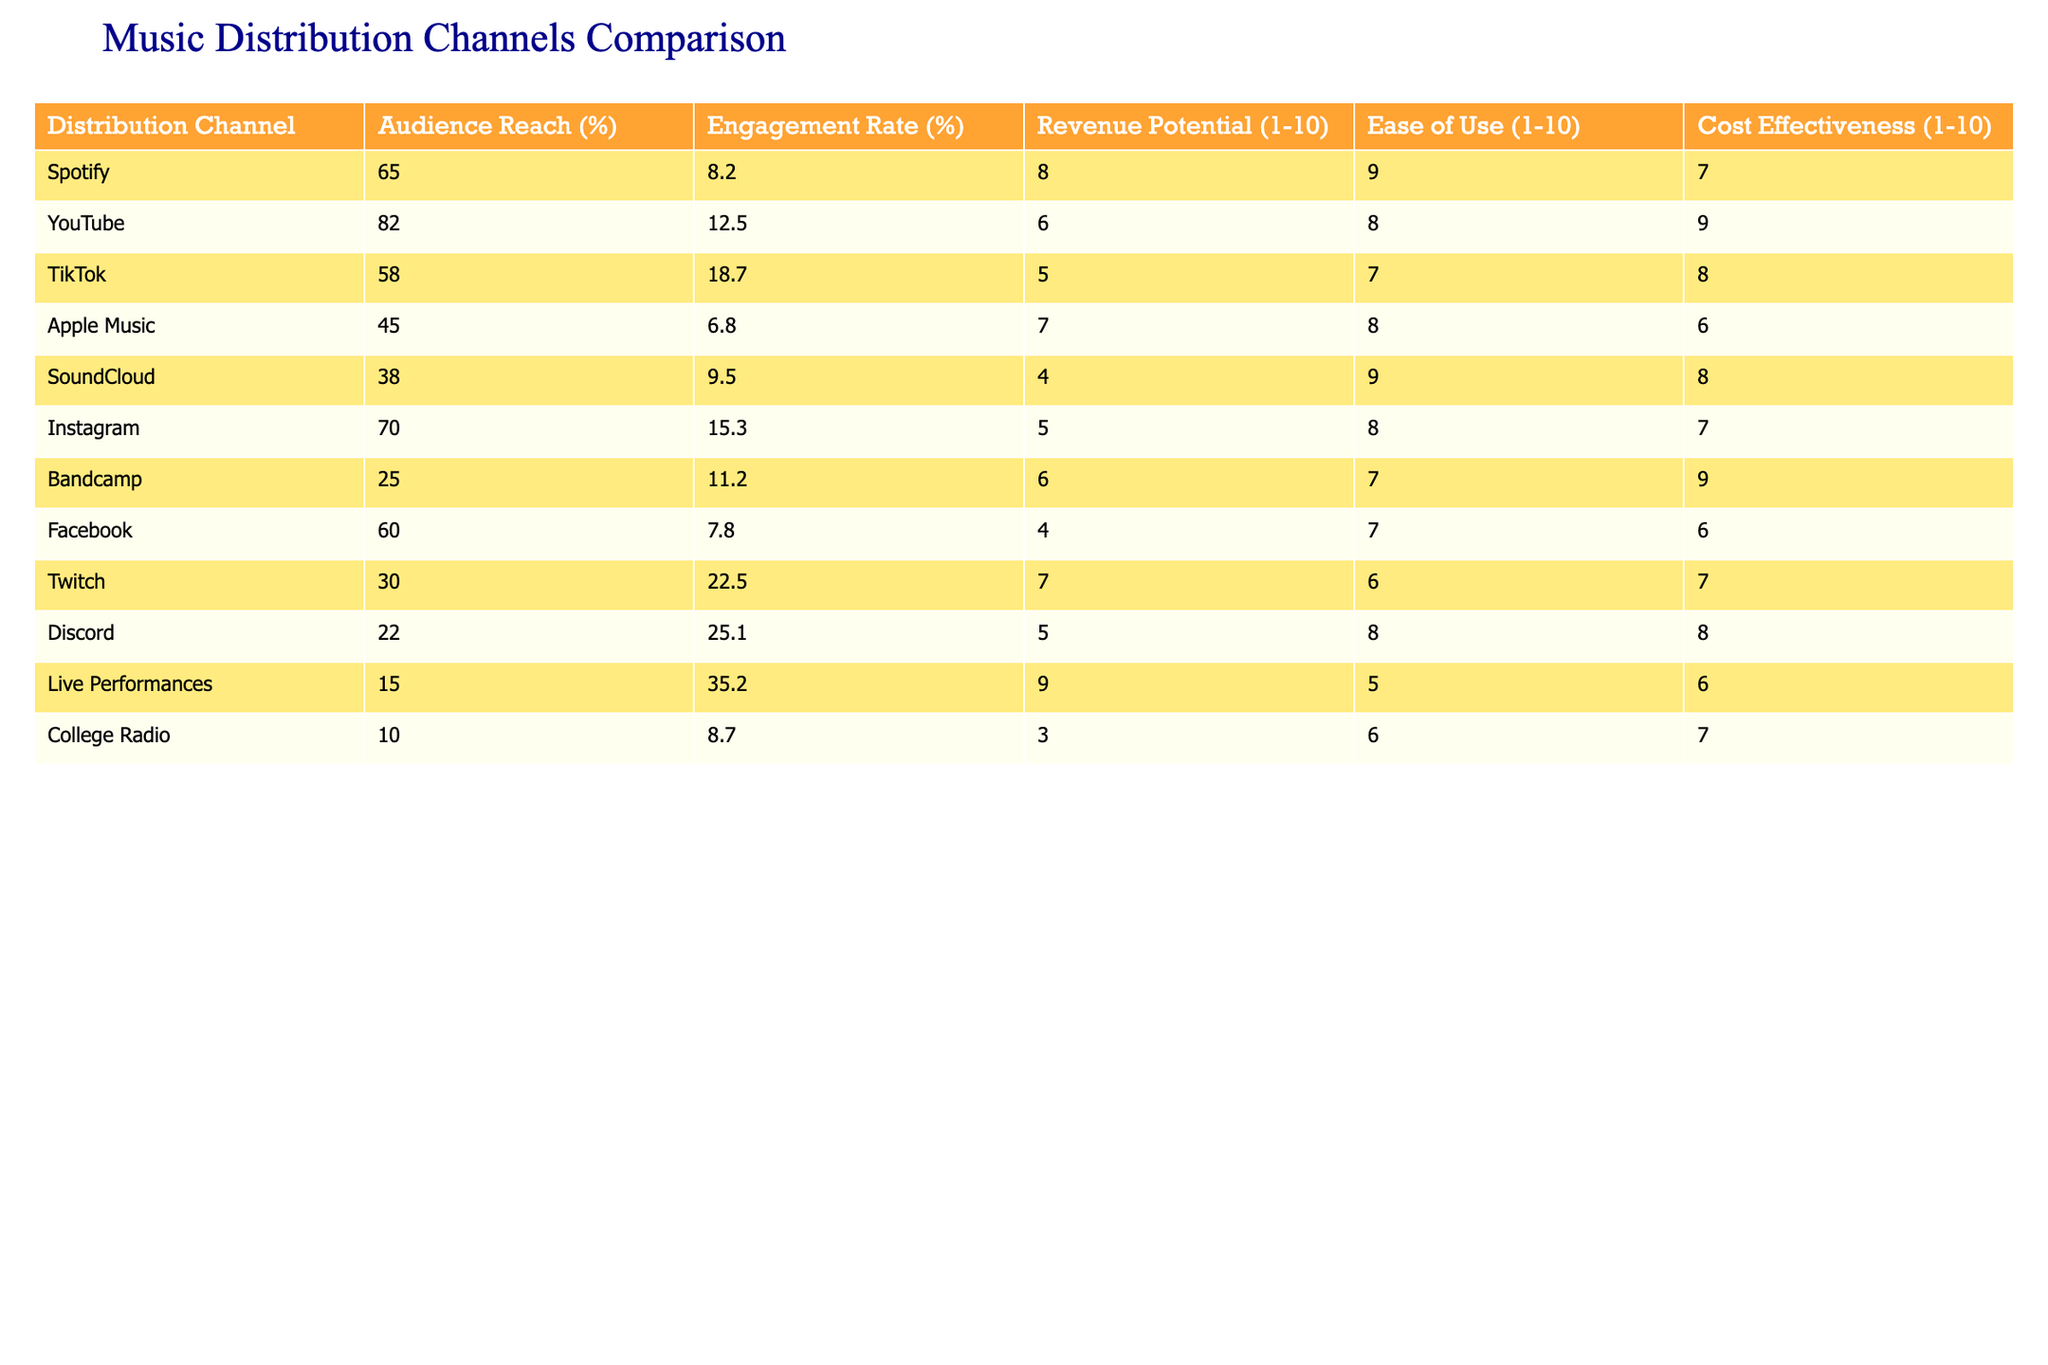What is the audience reach of YouTube? YouTube's audience reach is listed in the table under the "Audience Reach (%)" column, where it shows a value of 82.
Answer: 82 Which distribution channel has the highest engagement rate? The table displays the engagement rates for all channels, and upon comparing them, we find that Discord has the highest engagement rate at 25.1%.
Answer: 25.1 What is the average revenue potential of the music distribution channels listed? To find the average revenue potential, we add together the individual revenue potential scores: (8 + 6 + 5 + 7 + 4 + 5 + 6 + 4 + 7 + 3) = 55, and then divide by the number of channels (10), which gives us an average of 5.5.
Answer: 5.5 Is the engagement rate of Spotify greater than that of Apple Music? By comparing the engagement rates in the table, Spotify has an engagement rate of 8.2%, while Apple Music's is 6.8%. Since 8.2% is greater than 6.8%, the statement is true.
Answer: Yes Which distribution channel is the easiest to use, and what is its score? Looking at the "Ease of Use (1-10)" column, we identify the highest score among the distribution channels. Spotify has the highest score of 9, indicating it is the easiest to use.
Answer: Spotify, 9 What is the difference in audience reach between TikTok and SoundCloud? TikTok's audience reach is 58% and SoundCloud's is 38%. To find the difference, we subtract SoundCloud's reach from TikTok's: 58 - 38 = 20%.
Answer: 20% Which two channels have the same revenue potential score of 6? By checking the revenue potential scores, we find that both YouTube and Bandcamp have a score of 6, making them the two channels in question.
Answer: YouTube and Bandcamp Does Discord have a higher engagement rate than Live Performances? The table shows Discord has an engagement rate of 25.1%, while Live Performances has an engagement rate of 35.2%. Since 25.1% is less than 35.2%, the statement is false.
Answer: No What are the top three distribution channels based on audience reach? From the "Audience Reach (%)" column, we find the top three channels are YouTube (82%), Spotify (65%), and Facebook (60%).
Answer: YouTube, Spotify, Facebook 